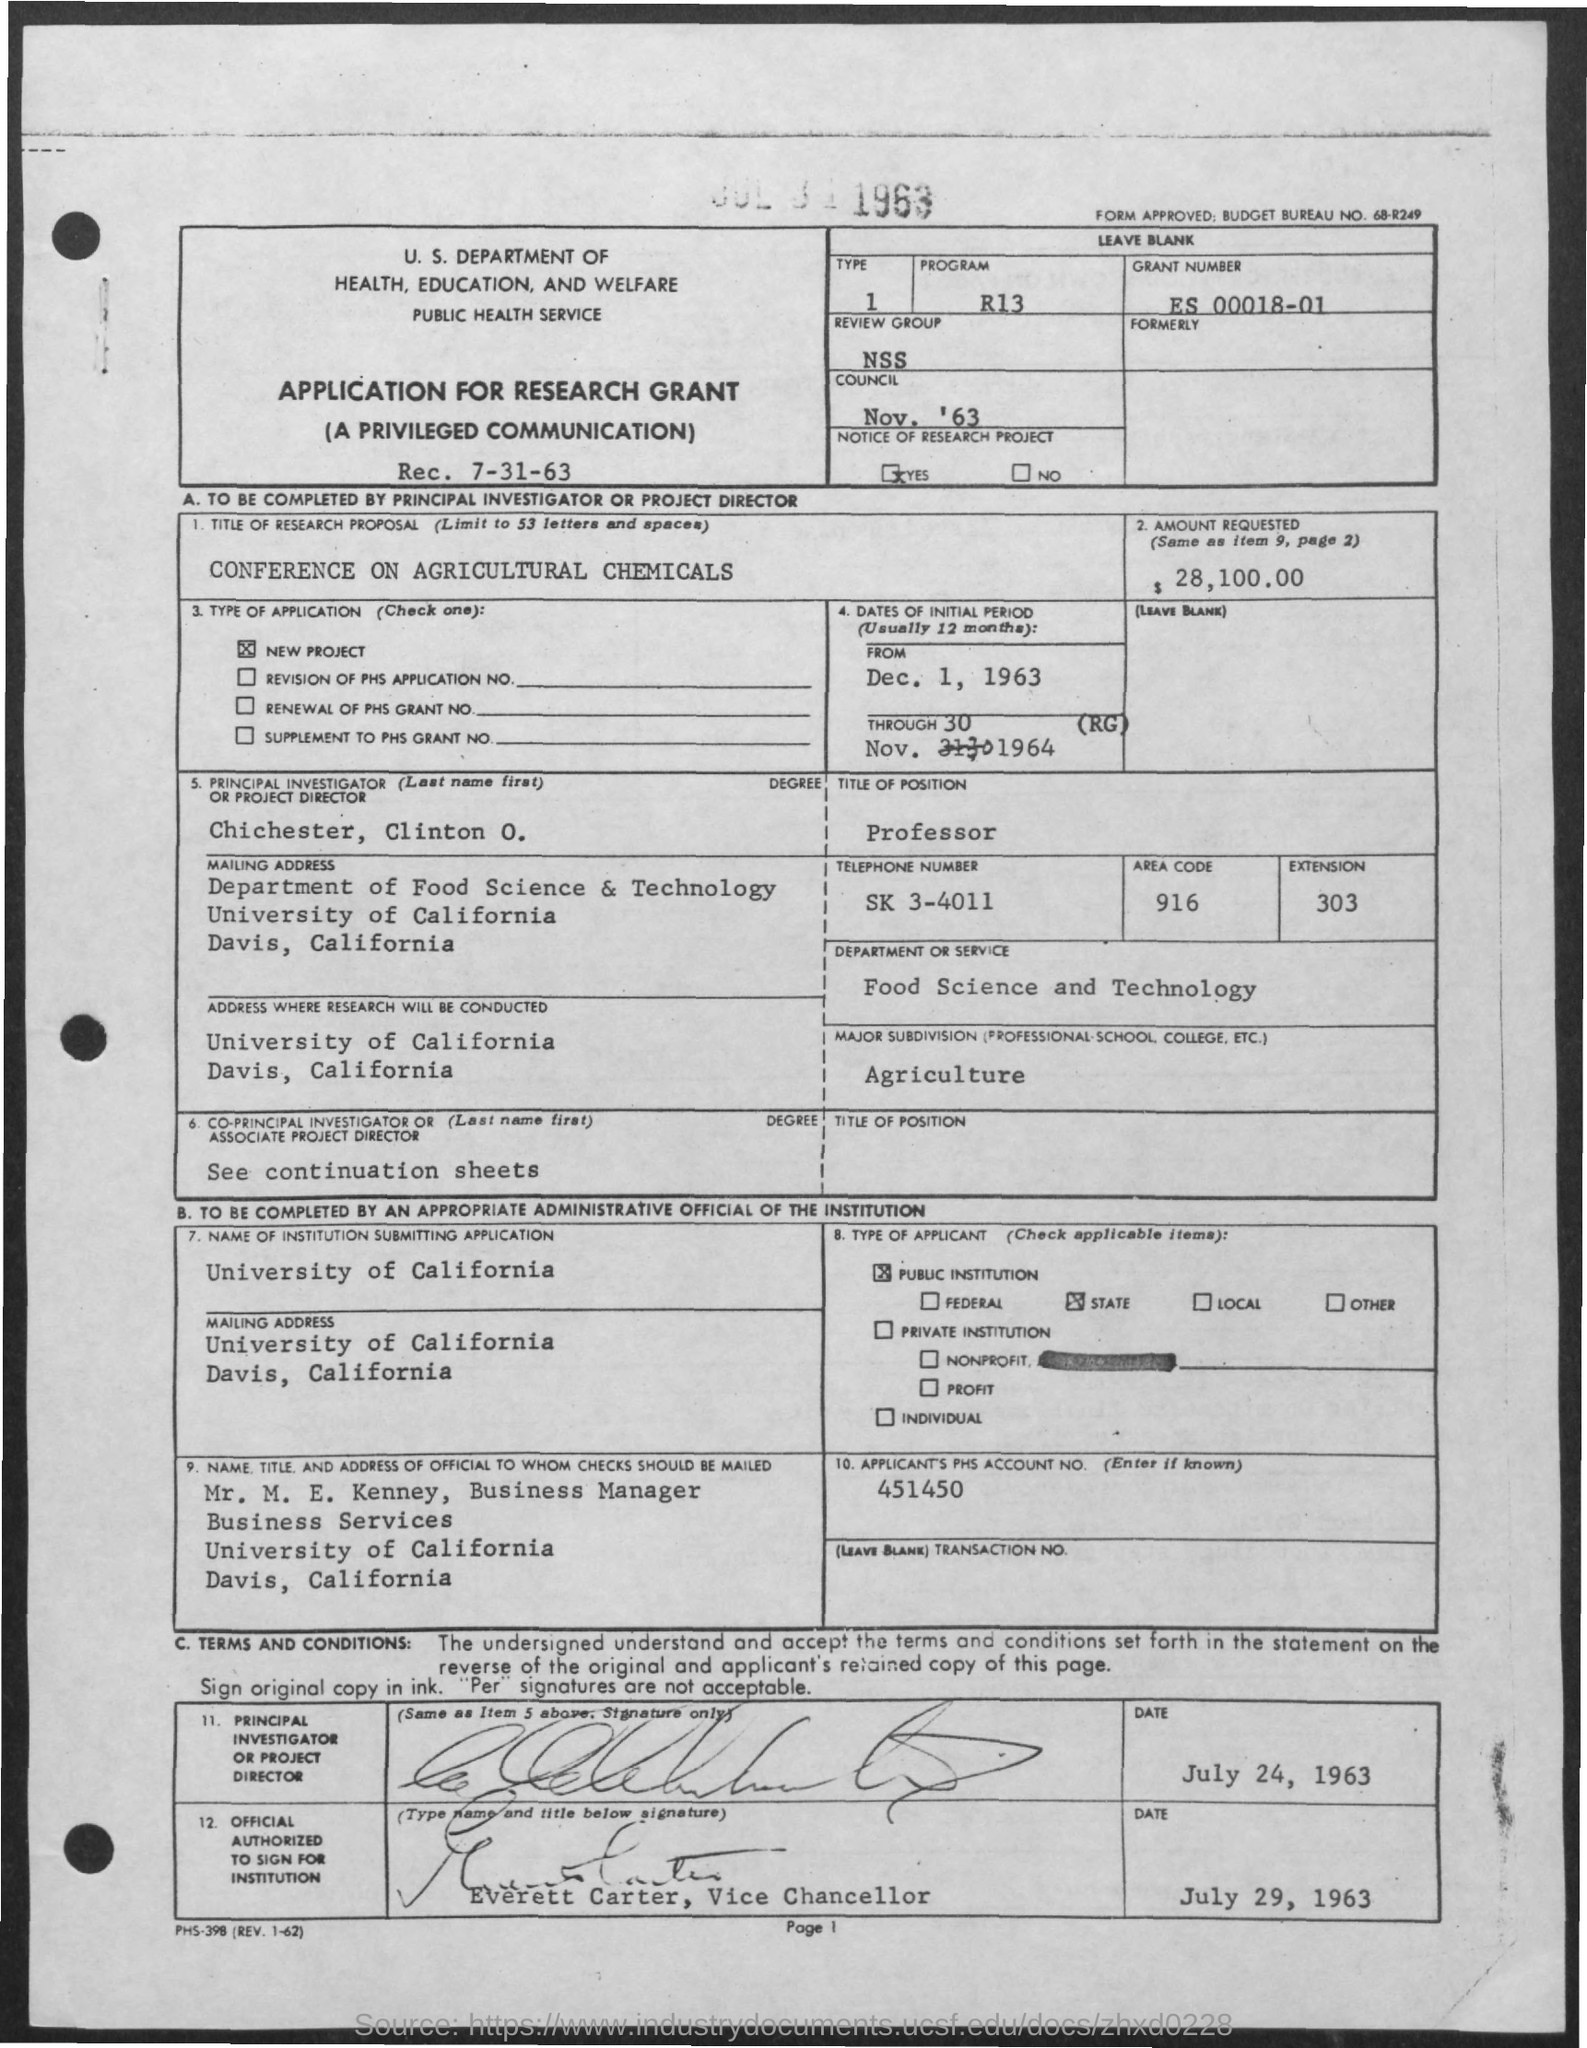What is the Grant Number mentioned in the application?
Your answer should be very brief. ES 00018-01. Which is the review group given in the application?
Provide a succinct answer. NSS. What is the amount requested for the research grant?
Ensure brevity in your answer.  $ 28,100.00. What is the name of the principal investigator or project director in the application?
Your answer should be very brief. Chichester, Clinton O. What is the title of position of Chichester, Clinton O. given in the application?
Offer a very short reply. Professor. What is the name of the official to whom the checks should be mailed?
Your answer should be very brief. Mr. M. E. Kenney. What is the designation of Mr. M. E. Kenney?
Ensure brevity in your answer.  Business Manager. What is the applicant's PHS Account No. given in the application?
Ensure brevity in your answer.  451450. 